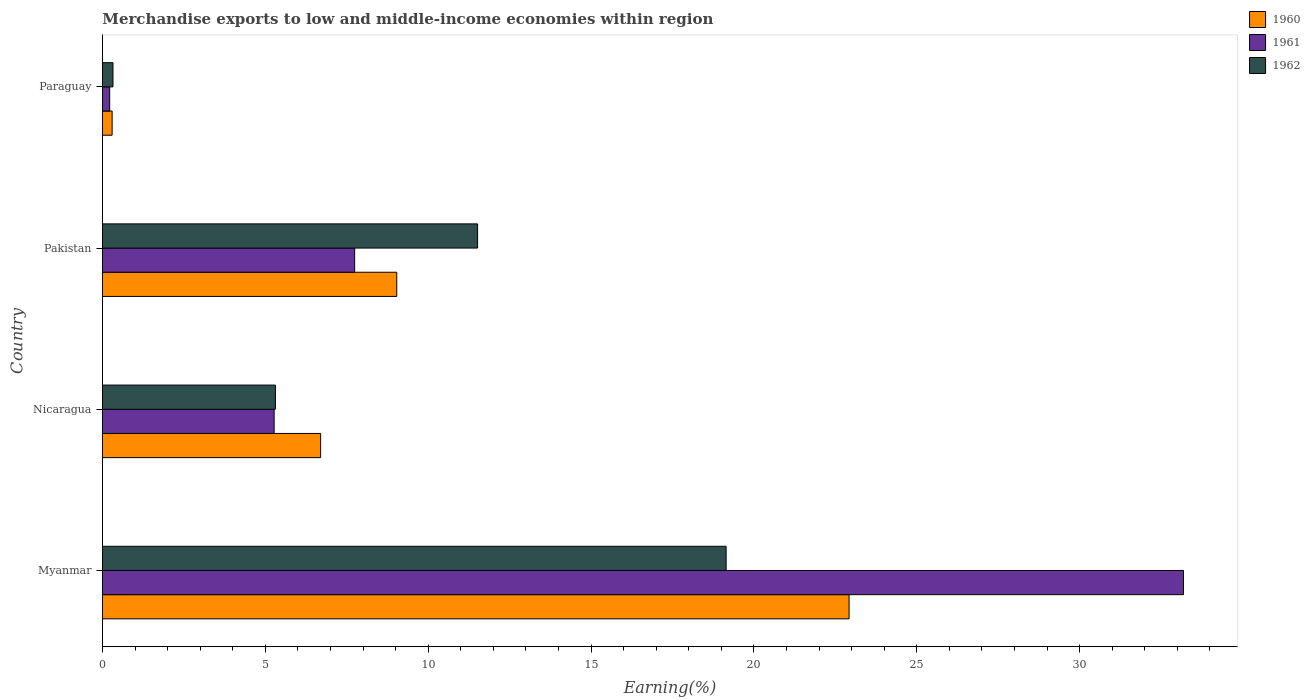Are the number of bars per tick equal to the number of legend labels?
Keep it short and to the point. Yes. How many bars are there on the 4th tick from the bottom?
Provide a succinct answer. 3. What is the percentage of amount earned from merchandise exports in 1961 in Myanmar?
Ensure brevity in your answer.  33.19. Across all countries, what is the maximum percentage of amount earned from merchandise exports in 1962?
Offer a very short reply. 19.15. Across all countries, what is the minimum percentage of amount earned from merchandise exports in 1962?
Offer a terse response. 0.32. In which country was the percentage of amount earned from merchandise exports in 1962 maximum?
Provide a short and direct response. Myanmar. In which country was the percentage of amount earned from merchandise exports in 1960 minimum?
Provide a succinct answer. Paraguay. What is the total percentage of amount earned from merchandise exports in 1960 in the graph?
Offer a very short reply. 38.95. What is the difference between the percentage of amount earned from merchandise exports in 1961 in Nicaragua and that in Pakistan?
Your response must be concise. -2.47. What is the difference between the percentage of amount earned from merchandise exports in 1960 in Myanmar and the percentage of amount earned from merchandise exports in 1962 in Nicaragua?
Make the answer very short. 17.61. What is the average percentage of amount earned from merchandise exports in 1962 per country?
Your response must be concise. 9.07. What is the difference between the percentage of amount earned from merchandise exports in 1960 and percentage of amount earned from merchandise exports in 1961 in Pakistan?
Keep it short and to the point. 1.29. In how many countries, is the percentage of amount earned from merchandise exports in 1962 greater than 14 %?
Provide a succinct answer. 1. What is the ratio of the percentage of amount earned from merchandise exports in 1962 in Nicaragua to that in Paraguay?
Make the answer very short. 16.45. What is the difference between the highest and the second highest percentage of amount earned from merchandise exports in 1962?
Offer a terse response. 7.63. What is the difference between the highest and the lowest percentage of amount earned from merchandise exports in 1960?
Your answer should be compact. 22.63. In how many countries, is the percentage of amount earned from merchandise exports in 1962 greater than the average percentage of amount earned from merchandise exports in 1962 taken over all countries?
Keep it short and to the point. 2. Is the sum of the percentage of amount earned from merchandise exports in 1960 in Myanmar and Pakistan greater than the maximum percentage of amount earned from merchandise exports in 1962 across all countries?
Provide a short and direct response. Yes. What does the 1st bar from the top in Pakistan represents?
Keep it short and to the point. 1962. Is it the case that in every country, the sum of the percentage of amount earned from merchandise exports in 1962 and percentage of amount earned from merchandise exports in 1961 is greater than the percentage of amount earned from merchandise exports in 1960?
Your response must be concise. Yes. Are all the bars in the graph horizontal?
Provide a short and direct response. Yes. Are the values on the major ticks of X-axis written in scientific E-notation?
Ensure brevity in your answer.  No. Does the graph contain any zero values?
Your response must be concise. No. Does the graph contain grids?
Your response must be concise. No. How many legend labels are there?
Ensure brevity in your answer.  3. How are the legend labels stacked?
Your response must be concise. Vertical. What is the title of the graph?
Your answer should be compact. Merchandise exports to low and middle-income economies within region. What is the label or title of the X-axis?
Give a very brief answer. Earning(%). What is the Earning(%) of 1960 in Myanmar?
Offer a terse response. 22.92. What is the Earning(%) of 1961 in Myanmar?
Provide a short and direct response. 33.19. What is the Earning(%) of 1962 in Myanmar?
Ensure brevity in your answer.  19.15. What is the Earning(%) of 1960 in Nicaragua?
Your answer should be compact. 6.7. What is the Earning(%) of 1961 in Nicaragua?
Make the answer very short. 5.27. What is the Earning(%) in 1962 in Nicaragua?
Make the answer very short. 5.31. What is the Earning(%) of 1960 in Pakistan?
Keep it short and to the point. 9.04. What is the Earning(%) of 1961 in Pakistan?
Provide a succinct answer. 7.74. What is the Earning(%) of 1962 in Pakistan?
Your response must be concise. 11.52. What is the Earning(%) of 1960 in Paraguay?
Keep it short and to the point. 0.3. What is the Earning(%) in 1961 in Paraguay?
Ensure brevity in your answer.  0.22. What is the Earning(%) in 1962 in Paraguay?
Ensure brevity in your answer.  0.32. Across all countries, what is the maximum Earning(%) of 1960?
Your answer should be very brief. 22.92. Across all countries, what is the maximum Earning(%) of 1961?
Keep it short and to the point. 33.19. Across all countries, what is the maximum Earning(%) in 1962?
Offer a very short reply. 19.15. Across all countries, what is the minimum Earning(%) of 1960?
Your answer should be compact. 0.3. Across all countries, what is the minimum Earning(%) in 1961?
Offer a terse response. 0.22. Across all countries, what is the minimum Earning(%) of 1962?
Make the answer very short. 0.32. What is the total Earning(%) in 1960 in the graph?
Your answer should be very brief. 38.95. What is the total Earning(%) of 1961 in the graph?
Offer a very short reply. 46.43. What is the total Earning(%) in 1962 in the graph?
Your response must be concise. 36.3. What is the difference between the Earning(%) of 1960 in Myanmar and that in Nicaragua?
Your answer should be compact. 16.22. What is the difference between the Earning(%) of 1961 in Myanmar and that in Nicaragua?
Give a very brief answer. 27.92. What is the difference between the Earning(%) of 1962 in Myanmar and that in Nicaragua?
Offer a very short reply. 13.84. What is the difference between the Earning(%) of 1960 in Myanmar and that in Pakistan?
Offer a very short reply. 13.89. What is the difference between the Earning(%) of 1961 in Myanmar and that in Pakistan?
Ensure brevity in your answer.  25.45. What is the difference between the Earning(%) in 1962 in Myanmar and that in Pakistan?
Make the answer very short. 7.63. What is the difference between the Earning(%) in 1960 in Myanmar and that in Paraguay?
Your answer should be compact. 22.63. What is the difference between the Earning(%) of 1961 in Myanmar and that in Paraguay?
Make the answer very short. 32.97. What is the difference between the Earning(%) in 1962 in Myanmar and that in Paraguay?
Ensure brevity in your answer.  18.83. What is the difference between the Earning(%) of 1960 in Nicaragua and that in Pakistan?
Keep it short and to the point. -2.34. What is the difference between the Earning(%) of 1961 in Nicaragua and that in Pakistan?
Keep it short and to the point. -2.47. What is the difference between the Earning(%) of 1962 in Nicaragua and that in Pakistan?
Make the answer very short. -6.21. What is the difference between the Earning(%) in 1960 in Nicaragua and that in Paraguay?
Give a very brief answer. 6.4. What is the difference between the Earning(%) in 1961 in Nicaragua and that in Paraguay?
Keep it short and to the point. 5.05. What is the difference between the Earning(%) of 1962 in Nicaragua and that in Paraguay?
Make the answer very short. 4.99. What is the difference between the Earning(%) in 1960 in Pakistan and that in Paraguay?
Make the answer very short. 8.74. What is the difference between the Earning(%) of 1961 in Pakistan and that in Paraguay?
Keep it short and to the point. 7.52. What is the difference between the Earning(%) of 1962 in Pakistan and that in Paraguay?
Give a very brief answer. 11.19. What is the difference between the Earning(%) in 1960 in Myanmar and the Earning(%) in 1961 in Nicaragua?
Make the answer very short. 17.65. What is the difference between the Earning(%) of 1960 in Myanmar and the Earning(%) of 1962 in Nicaragua?
Your response must be concise. 17.61. What is the difference between the Earning(%) in 1961 in Myanmar and the Earning(%) in 1962 in Nicaragua?
Provide a succinct answer. 27.88. What is the difference between the Earning(%) of 1960 in Myanmar and the Earning(%) of 1961 in Pakistan?
Your answer should be compact. 15.18. What is the difference between the Earning(%) in 1960 in Myanmar and the Earning(%) in 1962 in Pakistan?
Your answer should be compact. 11.41. What is the difference between the Earning(%) in 1961 in Myanmar and the Earning(%) in 1962 in Pakistan?
Ensure brevity in your answer.  21.67. What is the difference between the Earning(%) in 1960 in Myanmar and the Earning(%) in 1961 in Paraguay?
Provide a succinct answer. 22.7. What is the difference between the Earning(%) of 1960 in Myanmar and the Earning(%) of 1962 in Paraguay?
Give a very brief answer. 22.6. What is the difference between the Earning(%) of 1961 in Myanmar and the Earning(%) of 1962 in Paraguay?
Provide a short and direct response. 32.87. What is the difference between the Earning(%) in 1960 in Nicaragua and the Earning(%) in 1961 in Pakistan?
Ensure brevity in your answer.  -1.04. What is the difference between the Earning(%) of 1960 in Nicaragua and the Earning(%) of 1962 in Pakistan?
Give a very brief answer. -4.82. What is the difference between the Earning(%) of 1961 in Nicaragua and the Earning(%) of 1962 in Pakistan?
Your answer should be very brief. -6.25. What is the difference between the Earning(%) of 1960 in Nicaragua and the Earning(%) of 1961 in Paraguay?
Offer a terse response. 6.48. What is the difference between the Earning(%) in 1960 in Nicaragua and the Earning(%) in 1962 in Paraguay?
Your answer should be compact. 6.38. What is the difference between the Earning(%) of 1961 in Nicaragua and the Earning(%) of 1962 in Paraguay?
Offer a very short reply. 4.95. What is the difference between the Earning(%) of 1960 in Pakistan and the Earning(%) of 1961 in Paraguay?
Provide a short and direct response. 8.81. What is the difference between the Earning(%) of 1960 in Pakistan and the Earning(%) of 1962 in Paraguay?
Give a very brief answer. 8.71. What is the difference between the Earning(%) in 1961 in Pakistan and the Earning(%) in 1962 in Paraguay?
Keep it short and to the point. 7.42. What is the average Earning(%) of 1960 per country?
Make the answer very short. 9.74. What is the average Earning(%) of 1961 per country?
Give a very brief answer. 11.61. What is the average Earning(%) of 1962 per country?
Give a very brief answer. 9.07. What is the difference between the Earning(%) of 1960 and Earning(%) of 1961 in Myanmar?
Offer a very short reply. -10.27. What is the difference between the Earning(%) in 1960 and Earning(%) in 1962 in Myanmar?
Offer a very short reply. 3.78. What is the difference between the Earning(%) of 1961 and Earning(%) of 1962 in Myanmar?
Keep it short and to the point. 14.04. What is the difference between the Earning(%) of 1960 and Earning(%) of 1961 in Nicaragua?
Offer a very short reply. 1.43. What is the difference between the Earning(%) in 1960 and Earning(%) in 1962 in Nicaragua?
Keep it short and to the point. 1.39. What is the difference between the Earning(%) of 1961 and Earning(%) of 1962 in Nicaragua?
Offer a very short reply. -0.04. What is the difference between the Earning(%) in 1960 and Earning(%) in 1961 in Pakistan?
Offer a very short reply. 1.29. What is the difference between the Earning(%) in 1960 and Earning(%) in 1962 in Pakistan?
Offer a terse response. -2.48. What is the difference between the Earning(%) in 1961 and Earning(%) in 1962 in Pakistan?
Give a very brief answer. -3.77. What is the difference between the Earning(%) of 1960 and Earning(%) of 1961 in Paraguay?
Offer a terse response. 0.07. What is the difference between the Earning(%) in 1960 and Earning(%) in 1962 in Paraguay?
Give a very brief answer. -0.03. What is the difference between the Earning(%) in 1961 and Earning(%) in 1962 in Paraguay?
Provide a short and direct response. -0.1. What is the ratio of the Earning(%) of 1960 in Myanmar to that in Nicaragua?
Offer a very short reply. 3.42. What is the ratio of the Earning(%) in 1961 in Myanmar to that in Nicaragua?
Make the answer very short. 6.3. What is the ratio of the Earning(%) of 1962 in Myanmar to that in Nicaragua?
Ensure brevity in your answer.  3.61. What is the ratio of the Earning(%) of 1960 in Myanmar to that in Pakistan?
Ensure brevity in your answer.  2.54. What is the ratio of the Earning(%) of 1961 in Myanmar to that in Pakistan?
Your response must be concise. 4.29. What is the ratio of the Earning(%) in 1962 in Myanmar to that in Pakistan?
Keep it short and to the point. 1.66. What is the ratio of the Earning(%) of 1960 in Myanmar to that in Paraguay?
Offer a terse response. 77.3. What is the ratio of the Earning(%) in 1961 in Myanmar to that in Paraguay?
Ensure brevity in your answer.  149.73. What is the ratio of the Earning(%) of 1962 in Myanmar to that in Paraguay?
Provide a short and direct response. 59.34. What is the ratio of the Earning(%) in 1960 in Nicaragua to that in Pakistan?
Ensure brevity in your answer.  0.74. What is the ratio of the Earning(%) of 1961 in Nicaragua to that in Pakistan?
Offer a very short reply. 0.68. What is the ratio of the Earning(%) of 1962 in Nicaragua to that in Pakistan?
Your response must be concise. 0.46. What is the ratio of the Earning(%) of 1960 in Nicaragua to that in Paraguay?
Your answer should be compact. 22.59. What is the ratio of the Earning(%) in 1961 in Nicaragua to that in Paraguay?
Ensure brevity in your answer.  23.78. What is the ratio of the Earning(%) in 1962 in Nicaragua to that in Paraguay?
Offer a terse response. 16.45. What is the ratio of the Earning(%) in 1960 in Pakistan to that in Paraguay?
Offer a very short reply. 30.47. What is the ratio of the Earning(%) in 1961 in Pakistan to that in Paraguay?
Provide a short and direct response. 34.93. What is the ratio of the Earning(%) in 1962 in Pakistan to that in Paraguay?
Provide a succinct answer. 35.69. What is the difference between the highest and the second highest Earning(%) in 1960?
Your answer should be very brief. 13.89. What is the difference between the highest and the second highest Earning(%) in 1961?
Your answer should be compact. 25.45. What is the difference between the highest and the second highest Earning(%) of 1962?
Provide a succinct answer. 7.63. What is the difference between the highest and the lowest Earning(%) of 1960?
Provide a succinct answer. 22.63. What is the difference between the highest and the lowest Earning(%) in 1961?
Ensure brevity in your answer.  32.97. What is the difference between the highest and the lowest Earning(%) of 1962?
Keep it short and to the point. 18.83. 